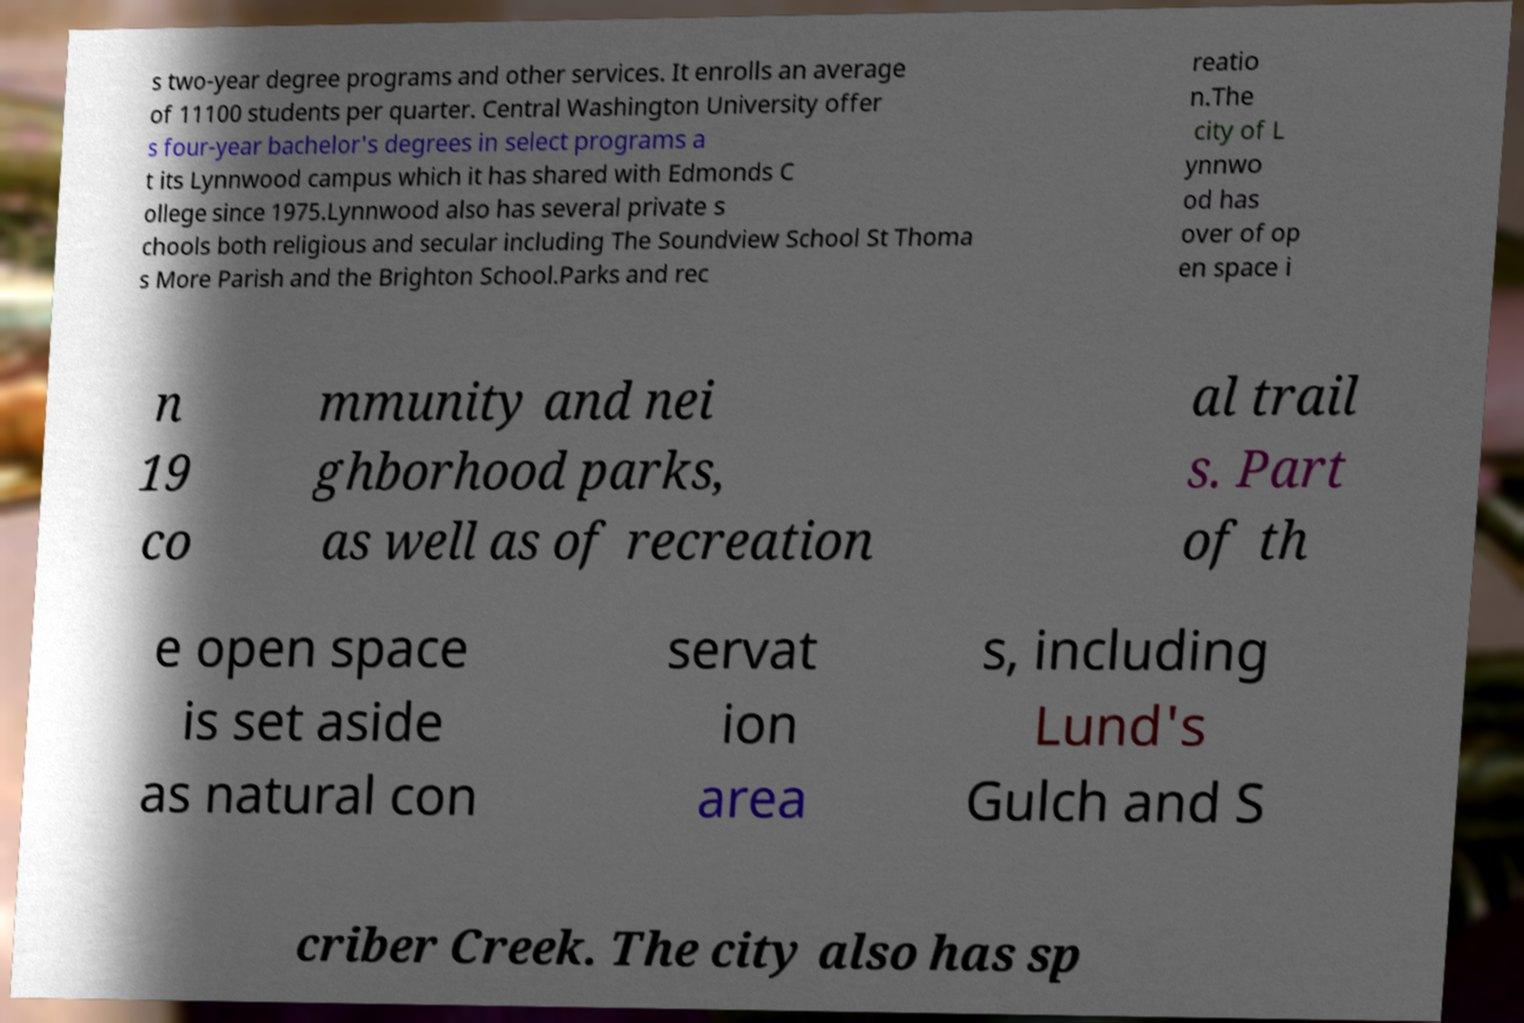Please read and relay the text visible in this image. What does it say? s two-year degree programs and other services. It enrolls an average of 11100 students per quarter. Central Washington University offer s four-year bachelor's degrees in select programs a t its Lynnwood campus which it has shared with Edmonds C ollege since 1975.Lynnwood also has several private s chools both religious and secular including The Soundview School St Thoma s More Parish and the Brighton School.Parks and rec reatio n.The city of L ynnwo od has over of op en space i n 19 co mmunity and nei ghborhood parks, as well as of recreation al trail s. Part of th e open space is set aside as natural con servat ion area s, including Lund's Gulch and S criber Creek. The city also has sp 